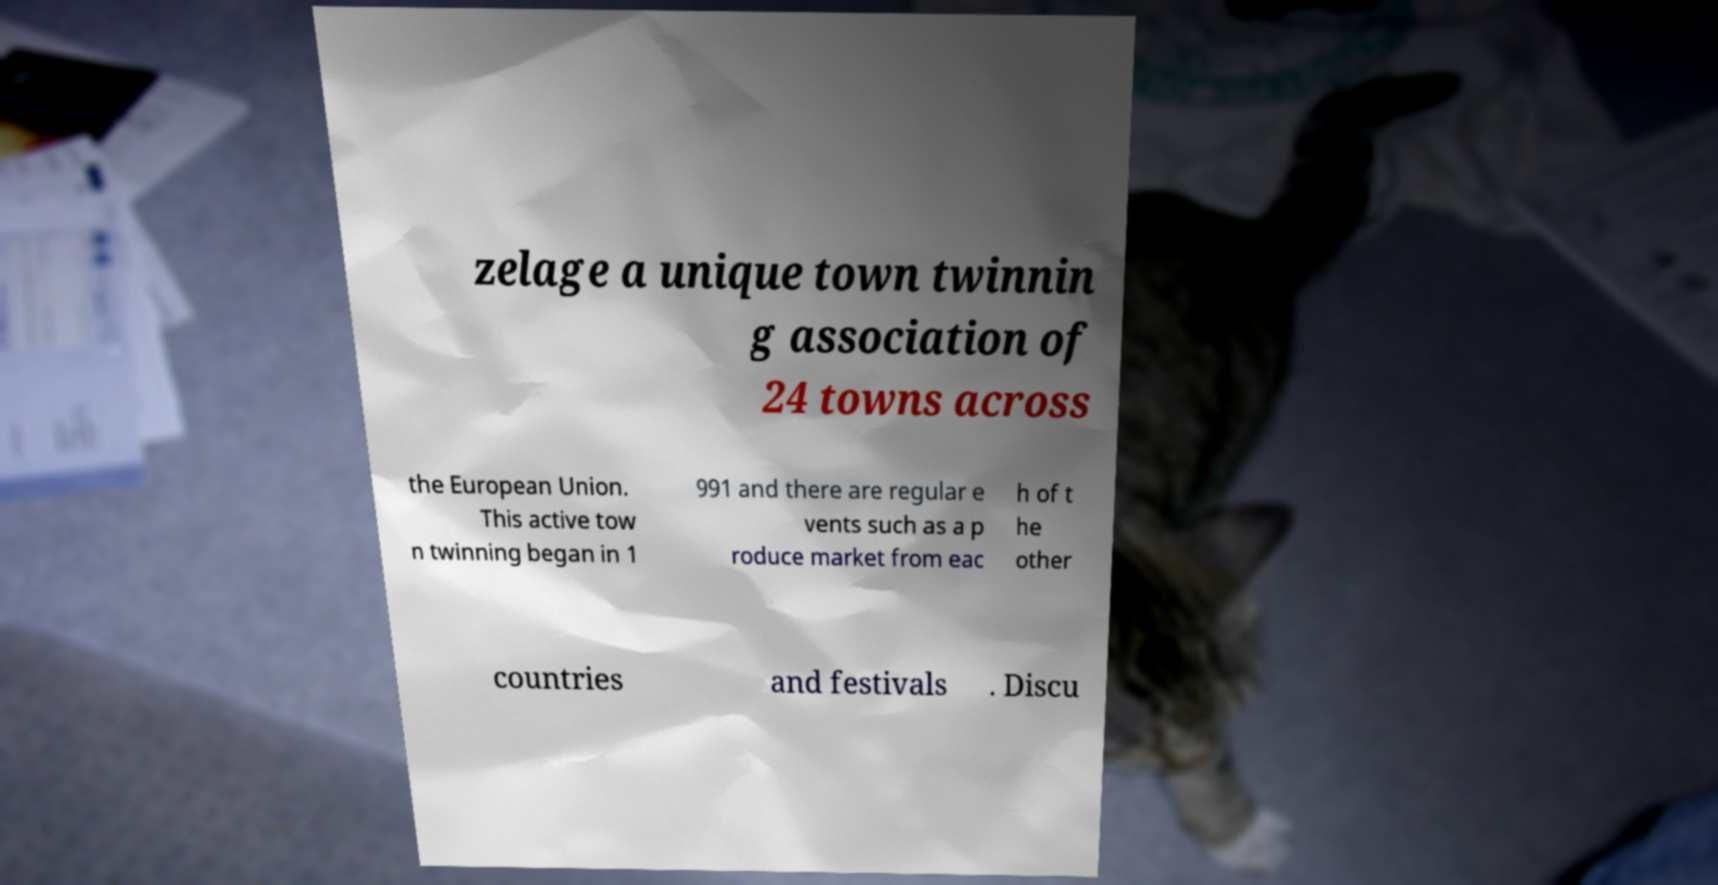Please identify and transcribe the text found in this image. zelage a unique town twinnin g association of 24 towns across the European Union. This active tow n twinning began in 1 991 and there are regular e vents such as a p roduce market from eac h of t he other countries and festivals . Discu 